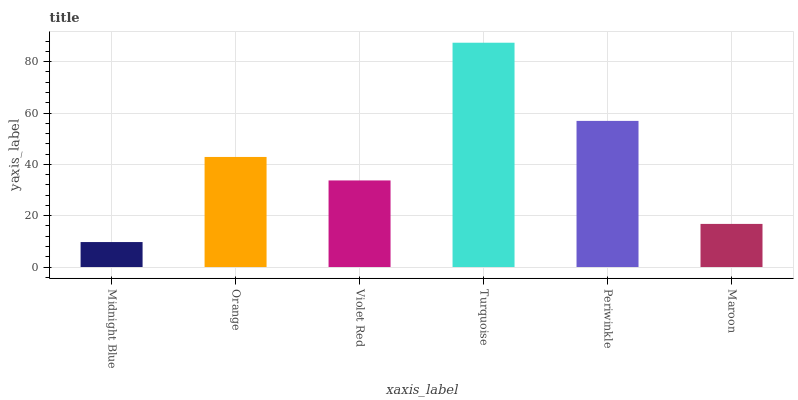Is Midnight Blue the minimum?
Answer yes or no. Yes. Is Turquoise the maximum?
Answer yes or no. Yes. Is Orange the minimum?
Answer yes or no. No. Is Orange the maximum?
Answer yes or no. No. Is Orange greater than Midnight Blue?
Answer yes or no. Yes. Is Midnight Blue less than Orange?
Answer yes or no. Yes. Is Midnight Blue greater than Orange?
Answer yes or no. No. Is Orange less than Midnight Blue?
Answer yes or no. No. Is Orange the high median?
Answer yes or no. Yes. Is Violet Red the low median?
Answer yes or no. Yes. Is Turquoise the high median?
Answer yes or no. No. Is Orange the low median?
Answer yes or no. No. 